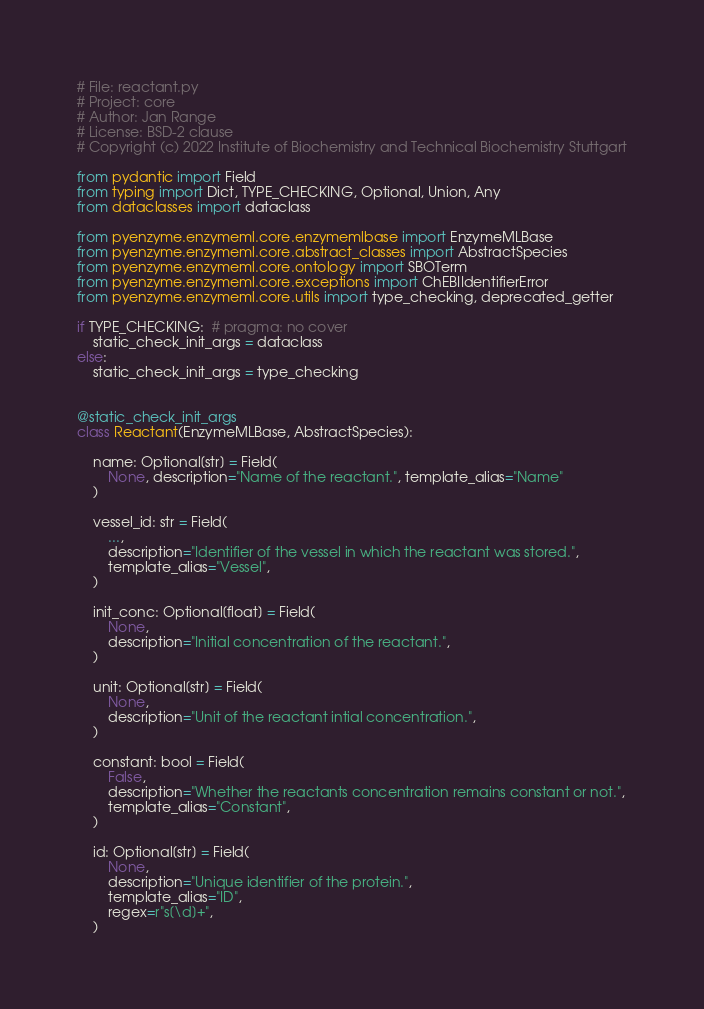<code> <loc_0><loc_0><loc_500><loc_500><_Python_># File: reactant.py
# Project: core
# Author: Jan Range
# License: BSD-2 clause
# Copyright (c) 2022 Institute of Biochemistry and Technical Biochemistry Stuttgart

from pydantic import Field
from typing import Dict, TYPE_CHECKING, Optional, Union, Any
from dataclasses import dataclass

from pyenzyme.enzymeml.core.enzymemlbase import EnzymeMLBase
from pyenzyme.enzymeml.core.abstract_classes import AbstractSpecies
from pyenzyme.enzymeml.core.ontology import SBOTerm
from pyenzyme.enzymeml.core.exceptions import ChEBIIdentifierError
from pyenzyme.enzymeml.core.utils import type_checking, deprecated_getter

if TYPE_CHECKING:  # pragma: no cover
    static_check_init_args = dataclass
else:
    static_check_init_args = type_checking


@static_check_init_args
class Reactant(EnzymeMLBase, AbstractSpecies):

    name: Optional[str] = Field(
        None, description="Name of the reactant.", template_alias="Name"
    )

    vessel_id: str = Field(
        ...,
        description="Identifier of the vessel in which the reactant was stored.",
        template_alias="Vessel",
    )

    init_conc: Optional[float] = Field(
        None,
        description="Initial concentration of the reactant.",
    )

    unit: Optional[str] = Field(
        None,
        description="Unit of the reactant intial concentration.",
    )

    constant: bool = Field(
        False,
        description="Whether the reactants concentration remains constant or not.",
        template_alias="Constant",
    )

    id: Optional[str] = Field(
        None,
        description="Unique identifier of the protein.",
        template_alias="ID",
        regex=r"s[\d]+",
    )
</code> 